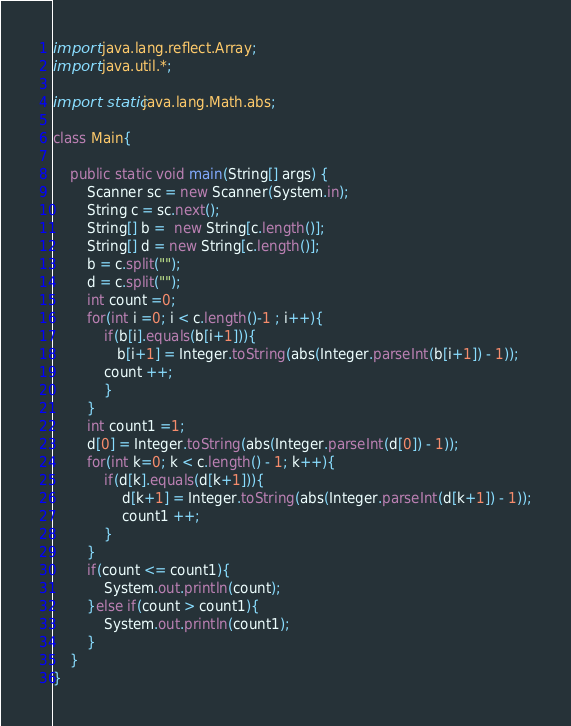<code> <loc_0><loc_0><loc_500><loc_500><_Java_>import java.lang.reflect.Array;
import java.util.*;

import static java.lang.Math.abs;

class Main{

    public static void main(String[] args) {
        Scanner sc = new Scanner(System.in);
        String c = sc.next();
        String[] b =  new String[c.length()];
        String[] d = new String[c.length()];
        b = c.split("");
        d = c.split("");
        int count =0;
        for(int i =0; i < c.length()-1 ; i++){
            if(b[i].equals(b[i+1])){
               b[i+1] = Integer.toString(abs(Integer.parseInt(b[i+1]) - 1));
            count ++;
            }
        }
        int count1 =1;
        d[0] = Integer.toString(abs(Integer.parseInt(d[0]) - 1));
        for(int k=0; k < c.length() - 1; k++){
            if(d[k].equals(d[k+1])){
                d[k+1] = Integer.toString(abs(Integer.parseInt(d[k+1]) - 1));
                count1 ++;
            }
        }
        if(count <= count1){
            System.out.println(count);
        }else if(count > count1){
            System.out.println(count1);
        }
    }
}
</code> 